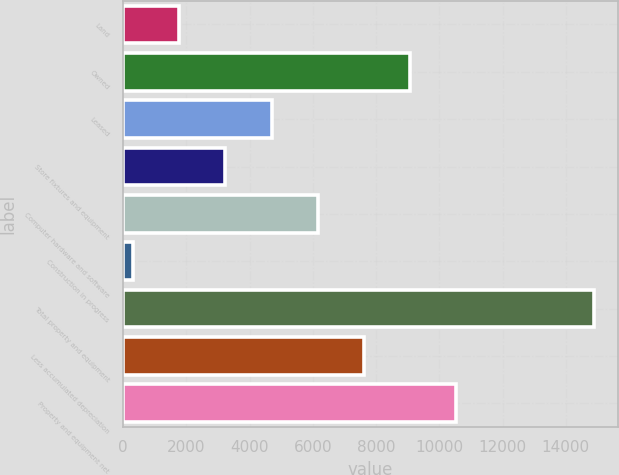Convert chart to OTSL. <chart><loc_0><loc_0><loc_500><loc_500><bar_chart><fcel>Land<fcel>Owned<fcel>Leased<fcel>Store fixtures and equipment<fcel>Computer hardware and software<fcel>Construction in progress<fcel>Total property and equipment<fcel>Less accumulated depreciation<fcel>Property and equipment net<nl><fcel>1775.3<fcel>9061.8<fcel>4689.9<fcel>3232.6<fcel>6147.2<fcel>318<fcel>14891<fcel>7604.5<fcel>10519.1<nl></chart> 